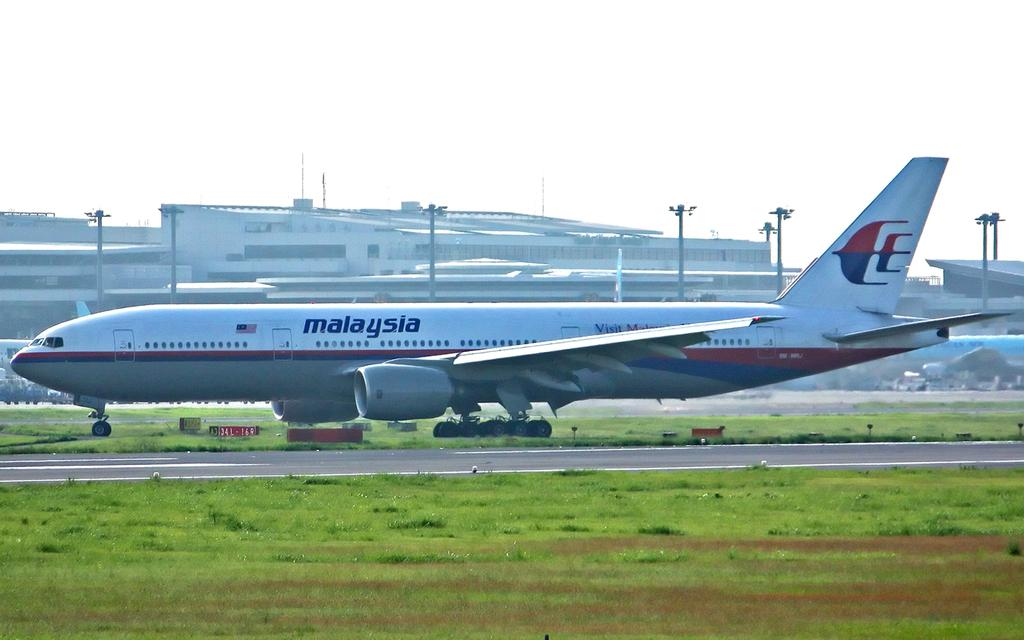<image>
Share a concise interpretation of the image provided. A Malaysia plane sits on the tarmac at an airport. 